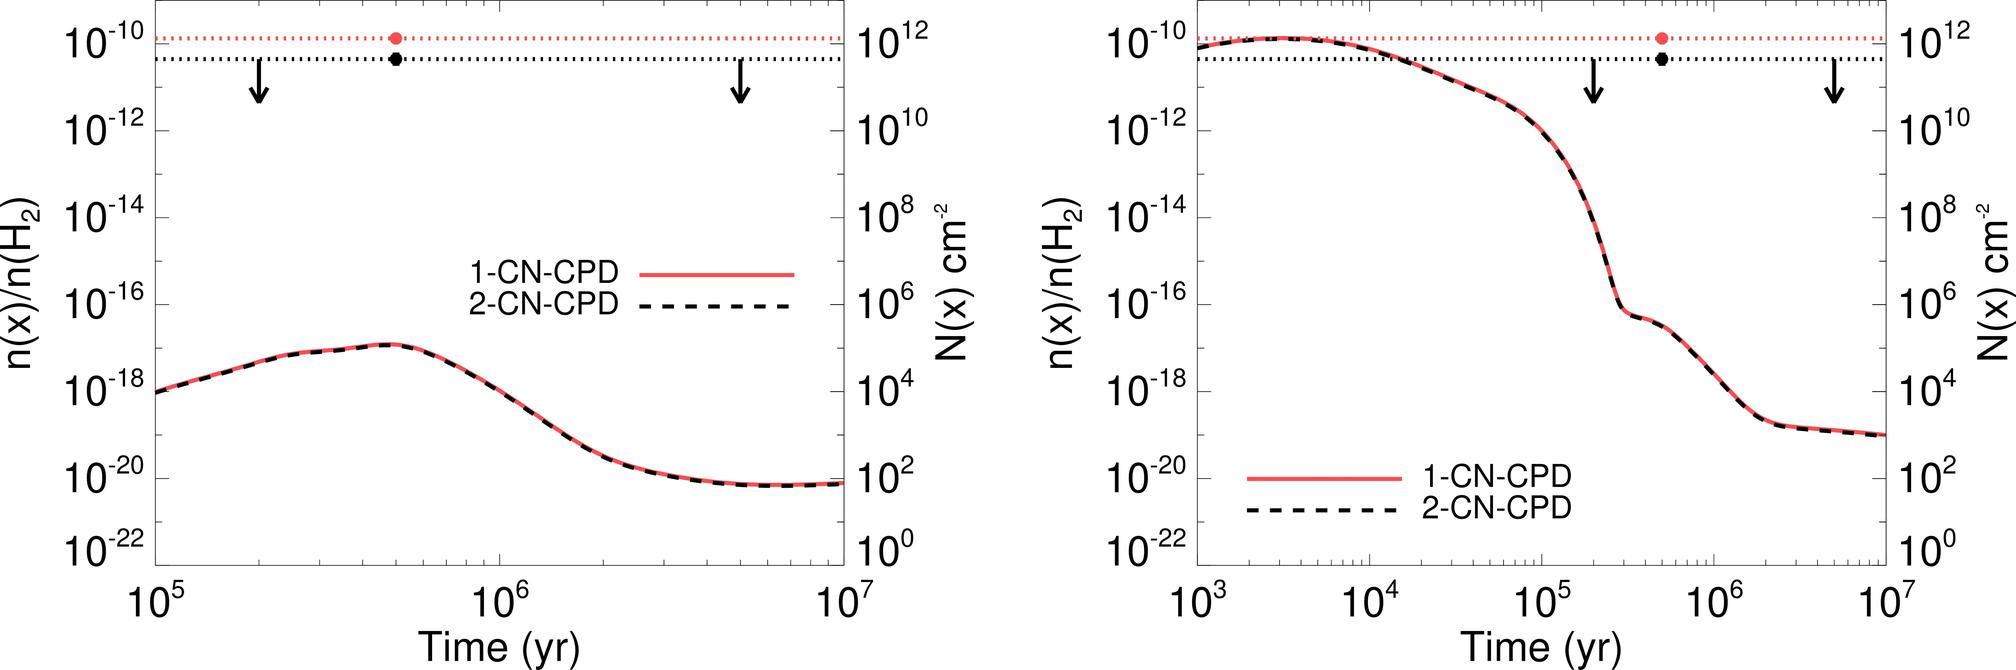Based on the trends shown in the graphs, what can be concluded about the time at which the concentration of both 1-CN-CPD and 2-CN-CPD begin to significantly decrease? A. At 10^5 years B. At 10^6 years C. After 10^7 years D. Between 10^5 and 10^6 years The graphs indicate that the significant decrease in concentration for both 1-CN-CPD and 2-CN-CPD starts to occur between 10^5 and 10^6 years, as shown by the steep downward trend beginning in this time range. Therefore, the correct answer is D. 